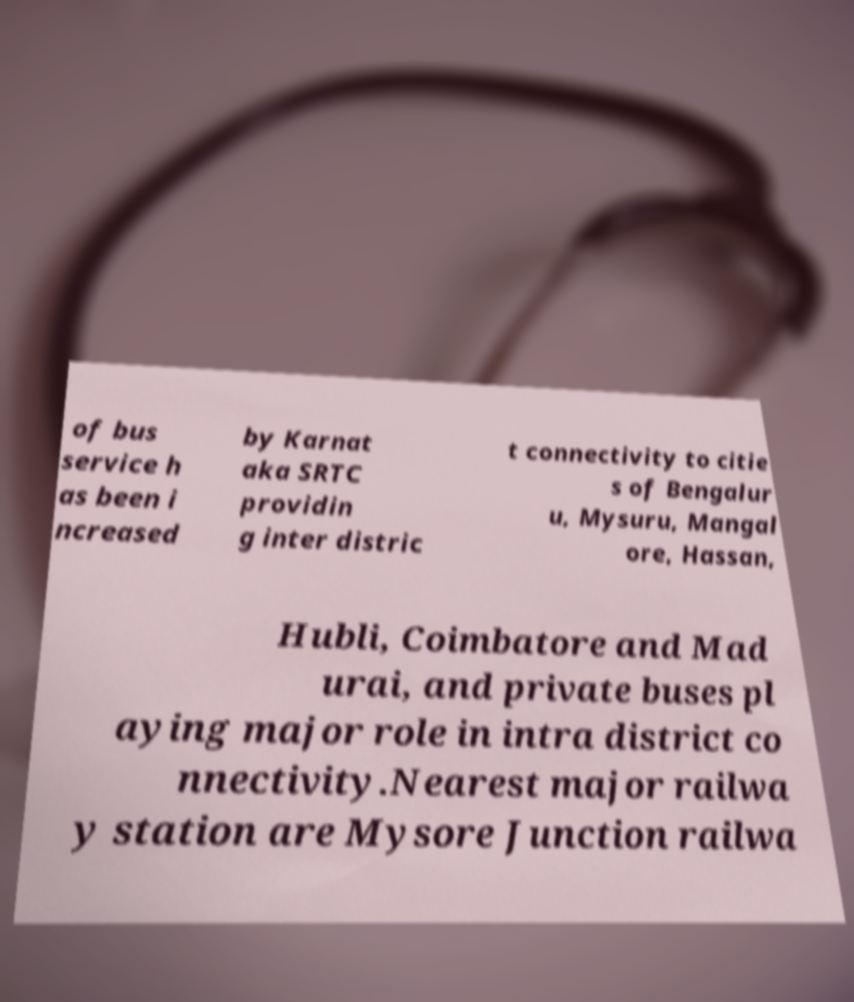There's text embedded in this image that I need extracted. Can you transcribe it verbatim? of bus service h as been i ncreased by Karnat aka SRTC providin g inter distric t connectivity to citie s of Bengalur u, Mysuru, Mangal ore, Hassan, Hubli, Coimbatore and Mad urai, and private buses pl aying major role in intra district co nnectivity.Nearest major railwa y station are Mysore Junction railwa 